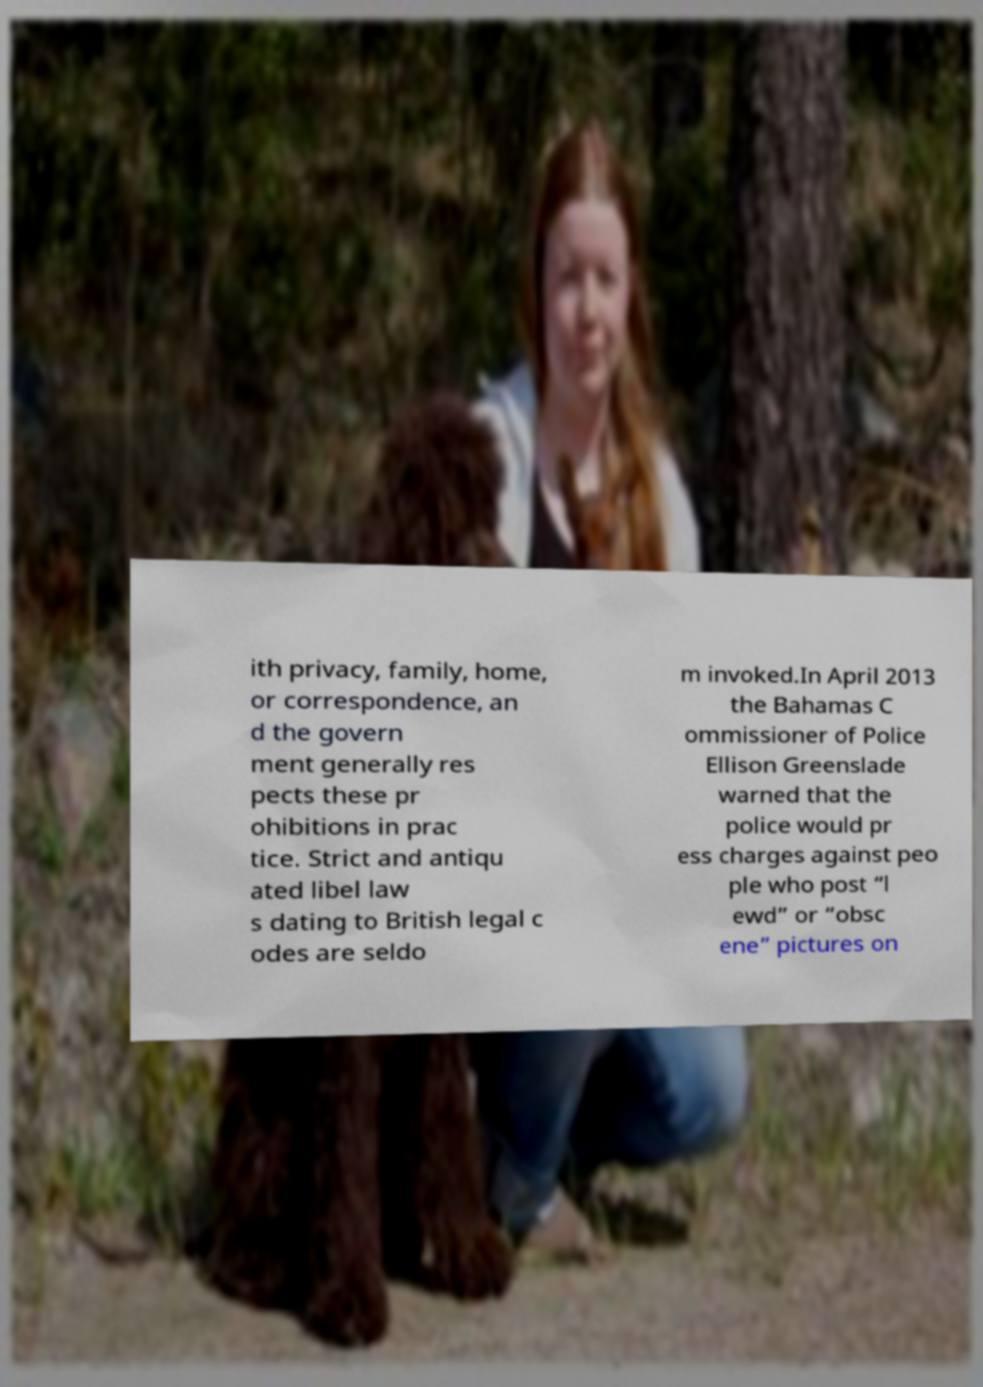For documentation purposes, I need the text within this image transcribed. Could you provide that? ith privacy, family, home, or correspondence, an d the govern ment generally res pects these pr ohibitions in prac tice. Strict and antiqu ated libel law s dating to British legal c odes are seldo m invoked.In April 2013 the Bahamas C ommissioner of Police Ellison Greenslade warned that the police would pr ess charges against peo ple who post “l ewd” or “obsc ene” pictures on 